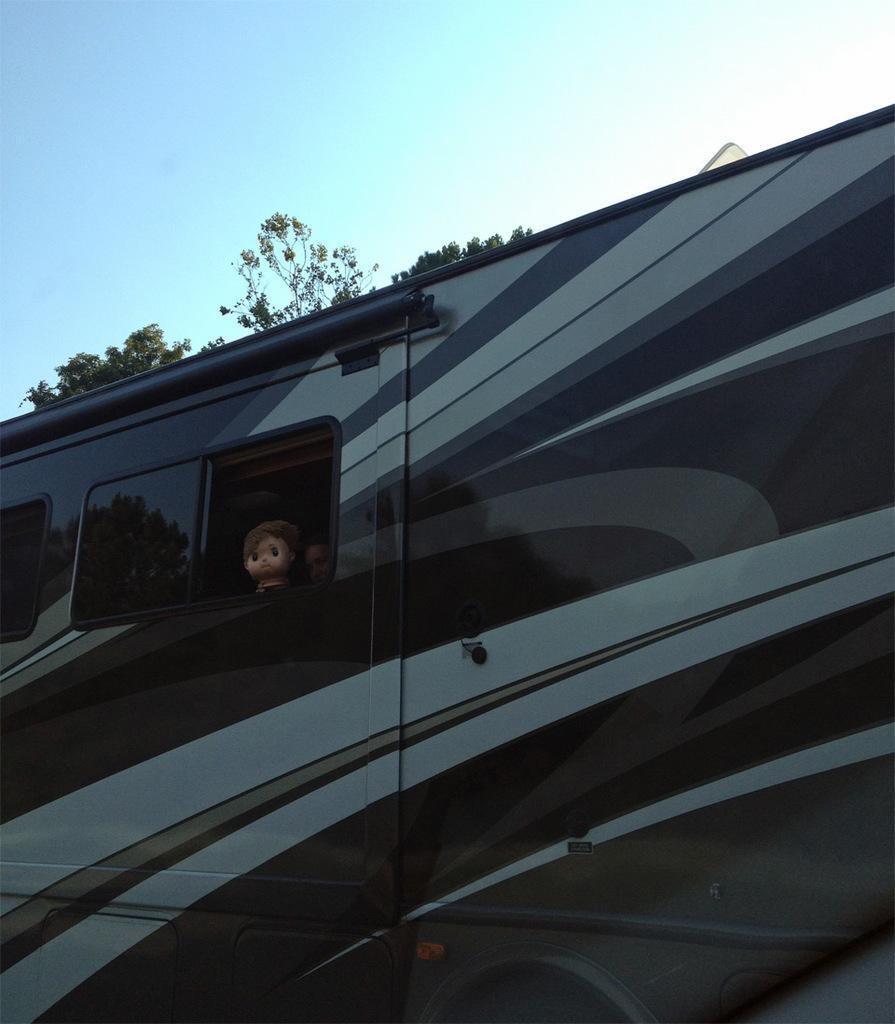In one or two sentences, can you explain what this image depicts? In the image we can see there is a vehicle and there is a window on the vehicle. There is a face of a doll in the window of the vehicle and there are trees. The sky is clear. 